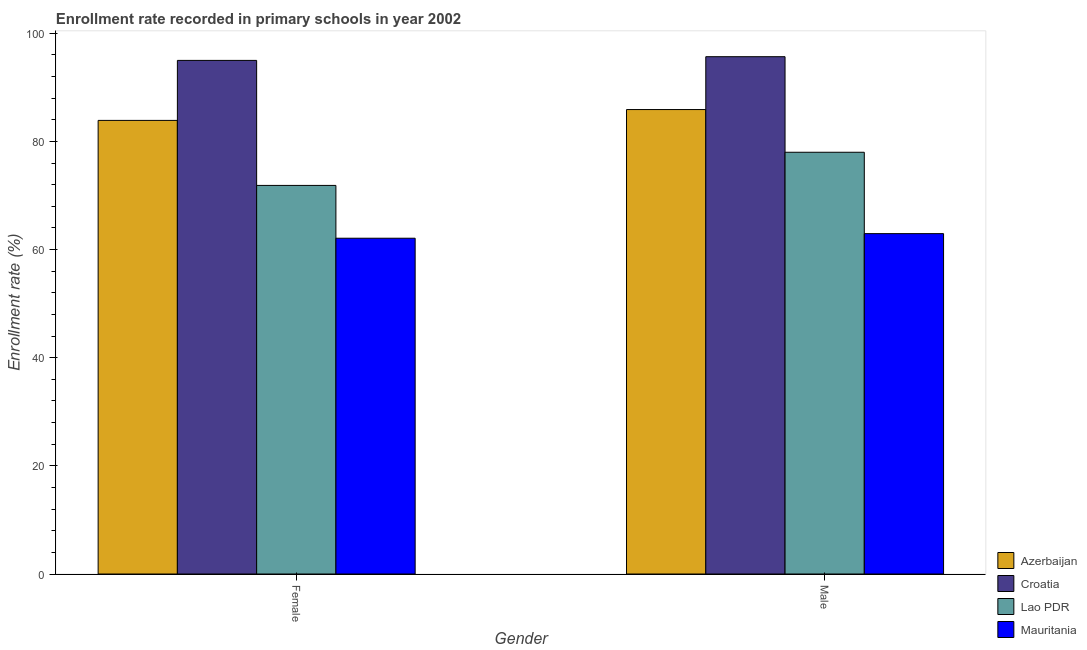How many different coloured bars are there?
Keep it short and to the point. 4. Are the number of bars per tick equal to the number of legend labels?
Provide a short and direct response. Yes. Are the number of bars on each tick of the X-axis equal?
Provide a short and direct response. Yes. How many bars are there on the 2nd tick from the left?
Keep it short and to the point. 4. What is the enrollment rate of male students in Lao PDR?
Give a very brief answer. 77.99. Across all countries, what is the maximum enrollment rate of female students?
Keep it short and to the point. 94.98. Across all countries, what is the minimum enrollment rate of male students?
Give a very brief answer. 62.94. In which country was the enrollment rate of male students maximum?
Offer a terse response. Croatia. In which country was the enrollment rate of male students minimum?
Keep it short and to the point. Mauritania. What is the total enrollment rate of male students in the graph?
Provide a succinct answer. 322.49. What is the difference between the enrollment rate of female students in Mauritania and that in Lao PDR?
Ensure brevity in your answer.  -9.76. What is the difference between the enrollment rate of male students in Mauritania and the enrollment rate of female students in Croatia?
Your response must be concise. -32.04. What is the average enrollment rate of female students per country?
Provide a short and direct response. 78.2. What is the difference between the enrollment rate of female students and enrollment rate of male students in Mauritania?
Ensure brevity in your answer.  -0.85. In how many countries, is the enrollment rate of female students greater than 4 %?
Ensure brevity in your answer.  4. What is the ratio of the enrollment rate of female students in Azerbaijan to that in Lao PDR?
Provide a succinct answer. 1.17. What does the 1st bar from the left in Male represents?
Ensure brevity in your answer.  Azerbaijan. What does the 1st bar from the right in Female represents?
Provide a short and direct response. Mauritania. How many bars are there?
Your answer should be compact. 8. Are all the bars in the graph horizontal?
Keep it short and to the point. No. How many countries are there in the graph?
Ensure brevity in your answer.  4. What is the difference between two consecutive major ticks on the Y-axis?
Offer a terse response. 20. Does the graph contain any zero values?
Provide a succinct answer. No. What is the title of the graph?
Provide a succinct answer. Enrollment rate recorded in primary schools in year 2002. Does "Cabo Verde" appear as one of the legend labels in the graph?
Make the answer very short. No. What is the label or title of the Y-axis?
Your answer should be compact. Enrollment rate (%). What is the Enrollment rate (%) of Azerbaijan in Female?
Offer a terse response. 83.88. What is the Enrollment rate (%) of Croatia in Female?
Your answer should be very brief. 94.98. What is the Enrollment rate (%) in Lao PDR in Female?
Ensure brevity in your answer.  71.86. What is the Enrollment rate (%) in Mauritania in Female?
Your answer should be compact. 62.09. What is the Enrollment rate (%) of Azerbaijan in Male?
Provide a succinct answer. 85.89. What is the Enrollment rate (%) of Croatia in Male?
Ensure brevity in your answer.  95.66. What is the Enrollment rate (%) of Lao PDR in Male?
Make the answer very short. 77.99. What is the Enrollment rate (%) of Mauritania in Male?
Ensure brevity in your answer.  62.94. Across all Gender, what is the maximum Enrollment rate (%) of Azerbaijan?
Offer a very short reply. 85.89. Across all Gender, what is the maximum Enrollment rate (%) of Croatia?
Provide a succinct answer. 95.66. Across all Gender, what is the maximum Enrollment rate (%) of Lao PDR?
Your answer should be very brief. 77.99. Across all Gender, what is the maximum Enrollment rate (%) in Mauritania?
Offer a terse response. 62.94. Across all Gender, what is the minimum Enrollment rate (%) of Azerbaijan?
Provide a short and direct response. 83.88. Across all Gender, what is the minimum Enrollment rate (%) in Croatia?
Keep it short and to the point. 94.98. Across all Gender, what is the minimum Enrollment rate (%) of Lao PDR?
Your response must be concise. 71.86. Across all Gender, what is the minimum Enrollment rate (%) of Mauritania?
Offer a very short reply. 62.09. What is the total Enrollment rate (%) in Azerbaijan in the graph?
Offer a very short reply. 169.77. What is the total Enrollment rate (%) in Croatia in the graph?
Your response must be concise. 190.64. What is the total Enrollment rate (%) of Lao PDR in the graph?
Offer a very short reply. 149.85. What is the total Enrollment rate (%) in Mauritania in the graph?
Your answer should be compact. 125.04. What is the difference between the Enrollment rate (%) in Azerbaijan in Female and that in Male?
Keep it short and to the point. -2.01. What is the difference between the Enrollment rate (%) in Croatia in Female and that in Male?
Ensure brevity in your answer.  -0.69. What is the difference between the Enrollment rate (%) in Lao PDR in Female and that in Male?
Provide a succinct answer. -6.13. What is the difference between the Enrollment rate (%) of Mauritania in Female and that in Male?
Provide a short and direct response. -0.85. What is the difference between the Enrollment rate (%) in Azerbaijan in Female and the Enrollment rate (%) in Croatia in Male?
Keep it short and to the point. -11.78. What is the difference between the Enrollment rate (%) of Azerbaijan in Female and the Enrollment rate (%) of Lao PDR in Male?
Ensure brevity in your answer.  5.89. What is the difference between the Enrollment rate (%) of Azerbaijan in Female and the Enrollment rate (%) of Mauritania in Male?
Keep it short and to the point. 20.94. What is the difference between the Enrollment rate (%) in Croatia in Female and the Enrollment rate (%) in Lao PDR in Male?
Your answer should be compact. 16.99. What is the difference between the Enrollment rate (%) of Croatia in Female and the Enrollment rate (%) of Mauritania in Male?
Your response must be concise. 32.04. What is the difference between the Enrollment rate (%) in Lao PDR in Female and the Enrollment rate (%) in Mauritania in Male?
Your answer should be compact. 8.92. What is the average Enrollment rate (%) in Azerbaijan per Gender?
Your answer should be compact. 84.89. What is the average Enrollment rate (%) in Croatia per Gender?
Offer a very short reply. 95.32. What is the average Enrollment rate (%) in Lao PDR per Gender?
Provide a short and direct response. 74.93. What is the average Enrollment rate (%) of Mauritania per Gender?
Provide a short and direct response. 62.52. What is the difference between the Enrollment rate (%) of Azerbaijan and Enrollment rate (%) of Croatia in Female?
Offer a very short reply. -11.1. What is the difference between the Enrollment rate (%) of Azerbaijan and Enrollment rate (%) of Lao PDR in Female?
Keep it short and to the point. 12.02. What is the difference between the Enrollment rate (%) in Azerbaijan and Enrollment rate (%) in Mauritania in Female?
Offer a very short reply. 21.79. What is the difference between the Enrollment rate (%) in Croatia and Enrollment rate (%) in Lao PDR in Female?
Make the answer very short. 23.12. What is the difference between the Enrollment rate (%) in Croatia and Enrollment rate (%) in Mauritania in Female?
Make the answer very short. 32.88. What is the difference between the Enrollment rate (%) in Lao PDR and Enrollment rate (%) in Mauritania in Female?
Make the answer very short. 9.76. What is the difference between the Enrollment rate (%) of Azerbaijan and Enrollment rate (%) of Croatia in Male?
Give a very brief answer. -9.78. What is the difference between the Enrollment rate (%) of Azerbaijan and Enrollment rate (%) of Lao PDR in Male?
Keep it short and to the point. 7.9. What is the difference between the Enrollment rate (%) of Azerbaijan and Enrollment rate (%) of Mauritania in Male?
Offer a very short reply. 22.95. What is the difference between the Enrollment rate (%) of Croatia and Enrollment rate (%) of Lao PDR in Male?
Your answer should be compact. 17.67. What is the difference between the Enrollment rate (%) in Croatia and Enrollment rate (%) in Mauritania in Male?
Give a very brief answer. 32.72. What is the difference between the Enrollment rate (%) of Lao PDR and Enrollment rate (%) of Mauritania in Male?
Your response must be concise. 15.05. What is the ratio of the Enrollment rate (%) of Azerbaijan in Female to that in Male?
Your response must be concise. 0.98. What is the ratio of the Enrollment rate (%) in Lao PDR in Female to that in Male?
Give a very brief answer. 0.92. What is the ratio of the Enrollment rate (%) in Mauritania in Female to that in Male?
Your answer should be very brief. 0.99. What is the difference between the highest and the second highest Enrollment rate (%) of Azerbaijan?
Provide a succinct answer. 2.01. What is the difference between the highest and the second highest Enrollment rate (%) in Croatia?
Your response must be concise. 0.69. What is the difference between the highest and the second highest Enrollment rate (%) in Lao PDR?
Keep it short and to the point. 6.13. What is the difference between the highest and the second highest Enrollment rate (%) in Mauritania?
Provide a succinct answer. 0.85. What is the difference between the highest and the lowest Enrollment rate (%) of Azerbaijan?
Provide a succinct answer. 2.01. What is the difference between the highest and the lowest Enrollment rate (%) of Croatia?
Your answer should be very brief. 0.69. What is the difference between the highest and the lowest Enrollment rate (%) in Lao PDR?
Provide a succinct answer. 6.13. What is the difference between the highest and the lowest Enrollment rate (%) of Mauritania?
Make the answer very short. 0.85. 